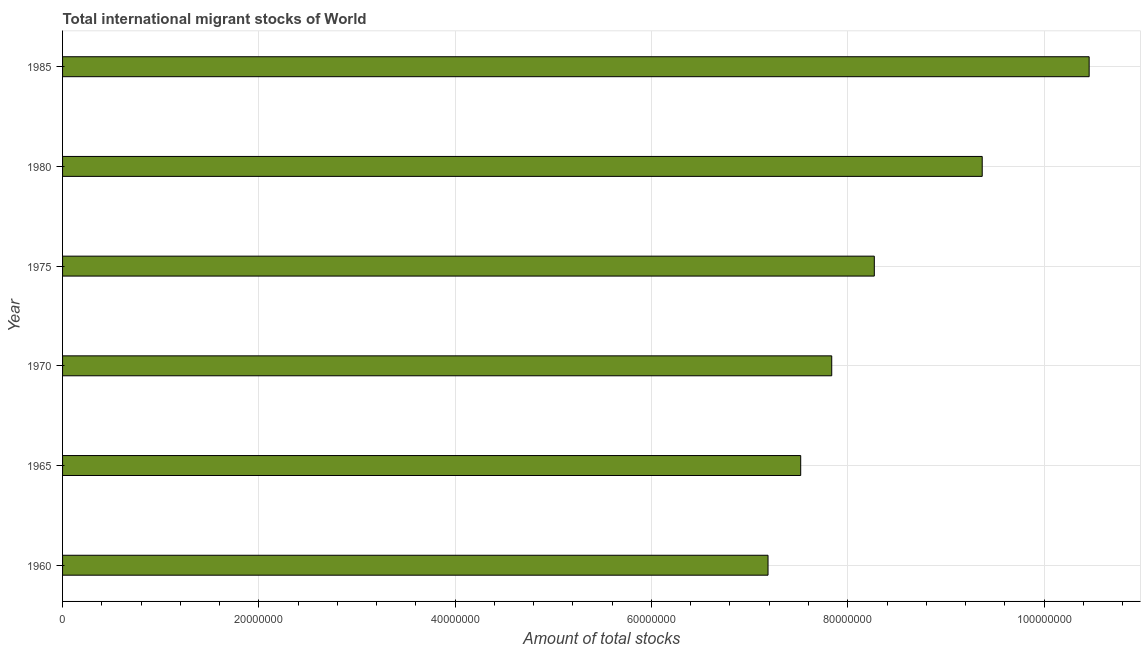Does the graph contain any zero values?
Keep it short and to the point. No. What is the title of the graph?
Your response must be concise. Total international migrant stocks of World. What is the label or title of the X-axis?
Offer a terse response. Amount of total stocks. What is the total number of international migrant stock in 1965?
Your answer should be compact. 7.52e+07. Across all years, what is the maximum total number of international migrant stock?
Your answer should be compact. 1.05e+08. Across all years, what is the minimum total number of international migrant stock?
Give a very brief answer. 7.19e+07. In which year was the total number of international migrant stock maximum?
Your answer should be very brief. 1985. What is the sum of the total number of international migrant stock?
Offer a terse response. 5.06e+08. What is the difference between the total number of international migrant stock in 1960 and 1965?
Provide a succinct answer. -3.33e+06. What is the average total number of international migrant stock per year?
Provide a short and direct response. 8.44e+07. What is the median total number of international migrant stock?
Provide a succinct answer. 8.05e+07. In how many years, is the total number of international migrant stock greater than 40000000 ?
Offer a very short reply. 6. Do a majority of the years between 1965 and 1970 (inclusive) have total number of international migrant stock greater than 68000000 ?
Offer a terse response. Yes. What is the ratio of the total number of international migrant stock in 1965 to that in 1980?
Your answer should be compact. 0.8. Is the total number of international migrant stock in 1965 less than that in 1980?
Provide a short and direct response. Yes. Is the difference between the total number of international migrant stock in 1960 and 1975 greater than the difference between any two years?
Keep it short and to the point. No. What is the difference between the highest and the second highest total number of international migrant stock?
Provide a short and direct response. 1.09e+07. Is the sum of the total number of international migrant stock in 1965 and 1970 greater than the maximum total number of international migrant stock across all years?
Ensure brevity in your answer.  Yes. What is the difference between the highest and the lowest total number of international migrant stock?
Keep it short and to the point. 3.27e+07. In how many years, is the total number of international migrant stock greater than the average total number of international migrant stock taken over all years?
Make the answer very short. 2. Are all the bars in the graph horizontal?
Your answer should be very brief. Yes. What is the difference between two consecutive major ticks on the X-axis?
Give a very brief answer. 2.00e+07. What is the Amount of total stocks of 1960?
Provide a short and direct response. 7.19e+07. What is the Amount of total stocks in 1965?
Give a very brief answer. 7.52e+07. What is the Amount of total stocks of 1970?
Your response must be concise. 7.84e+07. What is the Amount of total stocks of 1975?
Keep it short and to the point. 8.27e+07. What is the Amount of total stocks of 1980?
Ensure brevity in your answer.  9.37e+07. What is the Amount of total stocks of 1985?
Your response must be concise. 1.05e+08. What is the difference between the Amount of total stocks in 1960 and 1965?
Your answer should be compact. -3.33e+06. What is the difference between the Amount of total stocks in 1960 and 1970?
Provide a short and direct response. -6.49e+06. What is the difference between the Amount of total stocks in 1960 and 1975?
Your answer should be very brief. -1.08e+07. What is the difference between the Amount of total stocks in 1960 and 1980?
Your answer should be very brief. -2.18e+07. What is the difference between the Amount of total stocks in 1960 and 1985?
Offer a terse response. -3.27e+07. What is the difference between the Amount of total stocks in 1965 and 1970?
Keep it short and to the point. -3.16e+06. What is the difference between the Amount of total stocks in 1965 and 1975?
Ensure brevity in your answer.  -7.50e+06. What is the difference between the Amount of total stocks in 1965 and 1980?
Offer a terse response. -1.85e+07. What is the difference between the Amount of total stocks in 1965 and 1985?
Keep it short and to the point. -2.94e+07. What is the difference between the Amount of total stocks in 1970 and 1975?
Your response must be concise. -4.34e+06. What is the difference between the Amount of total stocks in 1970 and 1980?
Offer a very short reply. -1.53e+07. What is the difference between the Amount of total stocks in 1970 and 1985?
Your answer should be compact. -2.62e+07. What is the difference between the Amount of total stocks in 1975 and 1980?
Provide a short and direct response. -1.10e+07. What is the difference between the Amount of total stocks in 1975 and 1985?
Your answer should be compact. -2.19e+07. What is the difference between the Amount of total stocks in 1980 and 1985?
Ensure brevity in your answer.  -1.09e+07. What is the ratio of the Amount of total stocks in 1960 to that in 1965?
Your response must be concise. 0.96. What is the ratio of the Amount of total stocks in 1960 to that in 1970?
Keep it short and to the point. 0.92. What is the ratio of the Amount of total stocks in 1960 to that in 1975?
Keep it short and to the point. 0.87. What is the ratio of the Amount of total stocks in 1960 to that in 1980?
Your response must be concise. 0.77. What is the ratio of the Amount of total stocks in 1960 to that in 1985?
Give a very brief answer. 0.69. What is the ratio of the Amount of total stocks in 1965 to that in 1975?
Give a very brief answer. 0.91. What is the ratio of the Amount of total stocks in 1965 to that in 1980?
Keep it short and to the point. 0.8. What is the ratio of the Amount of total stocks in 1965 to that in 1985?
Offer a terse response. 0.72. What is the ratio of the Amount of total stocks in 1970 to that in 1975?
Keep it short and to the point. 0.95. What is the ratio of the Amount of total stocks in 1970 to that in 1980?
Offer a very short reply. 0.84. What is the ratio of the Amount of total stocks in 1970 to that in 1985?
Offer a very short reply. 0.75. What is the ratio of the Amount of total stocks in 1975 to that in 1980?
Offer a very short reply. 0.88. What is the ratio of the Amount of total stocks in 1975 to that in 1985?
Provide a succinct answer. 0.79. What is the ratio of the Amount of total stocks in 1980 to that in 1985?
Provide a short and direct response. 0.9. 